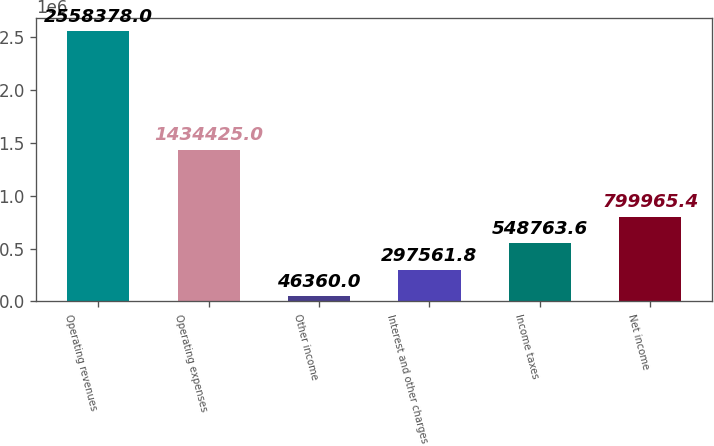Convert chart to OTSL. <chart><loc_0><loc_0><loc_500><loc_500><bar_chart><fcel>Operating revenues<fcel>Operating expenses<fcel>Other income<fcel>Interest and other charges<fcel>Income taxes<fcel>Net income<nl><fcel>2.55838e+06<fcel>1.43442e+06<fcel>46360<fcel>297562<fcel>548764<fcel>799965<nl></chart> 